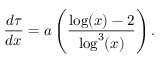Convert formula to latex. <formula><loc_0><loc_0><loc_500><loc_500>\frac { d \tau } { d x } = a \left ( \frac { \log ( x ) - 2 } { \log ^ { 3 } ( x ) } \right ) .</formula> 